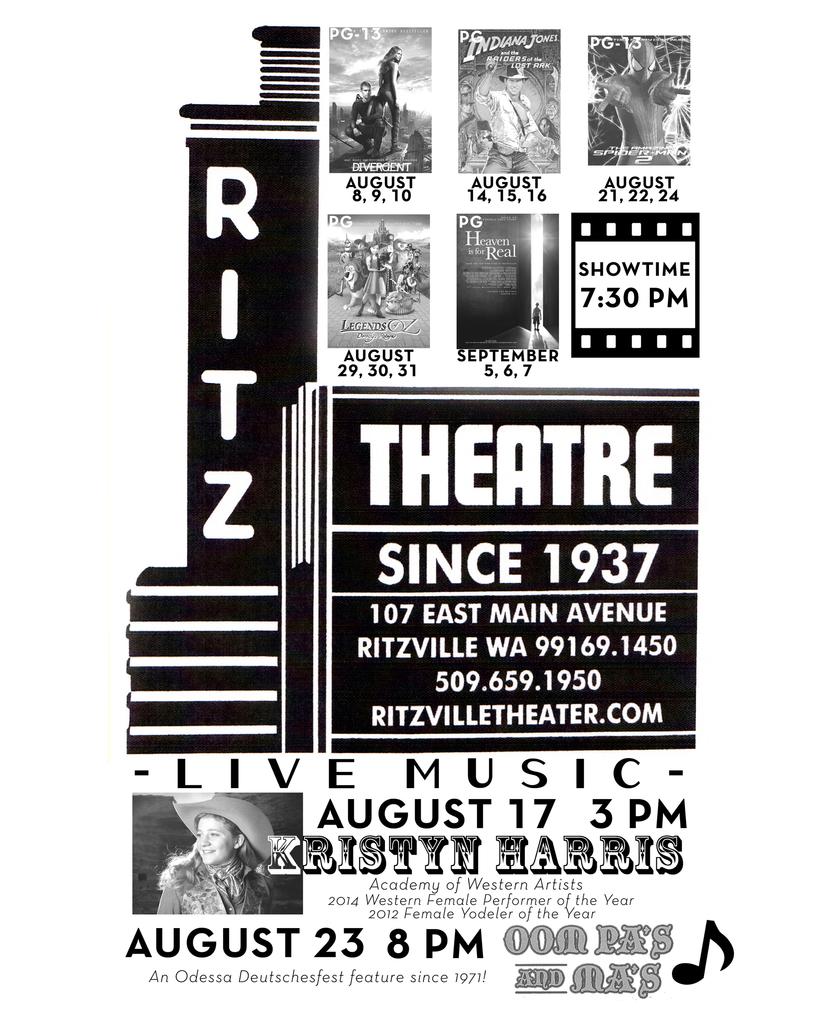How long has this theater been in business?
Your answer should be very brief. 1937. What year is this?
Your answer should be very brief. 1937. 